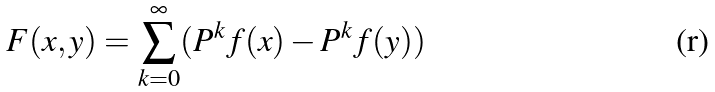Convert formula to latex. <formula><loc_0><loc_0><loc_500><loc_500>F ( x , y ) = \sum _ { k = 0 } ^ { \infty } ( P ^ { k } f ( x ) - P ^ { k } f ( y ) )</formula> 